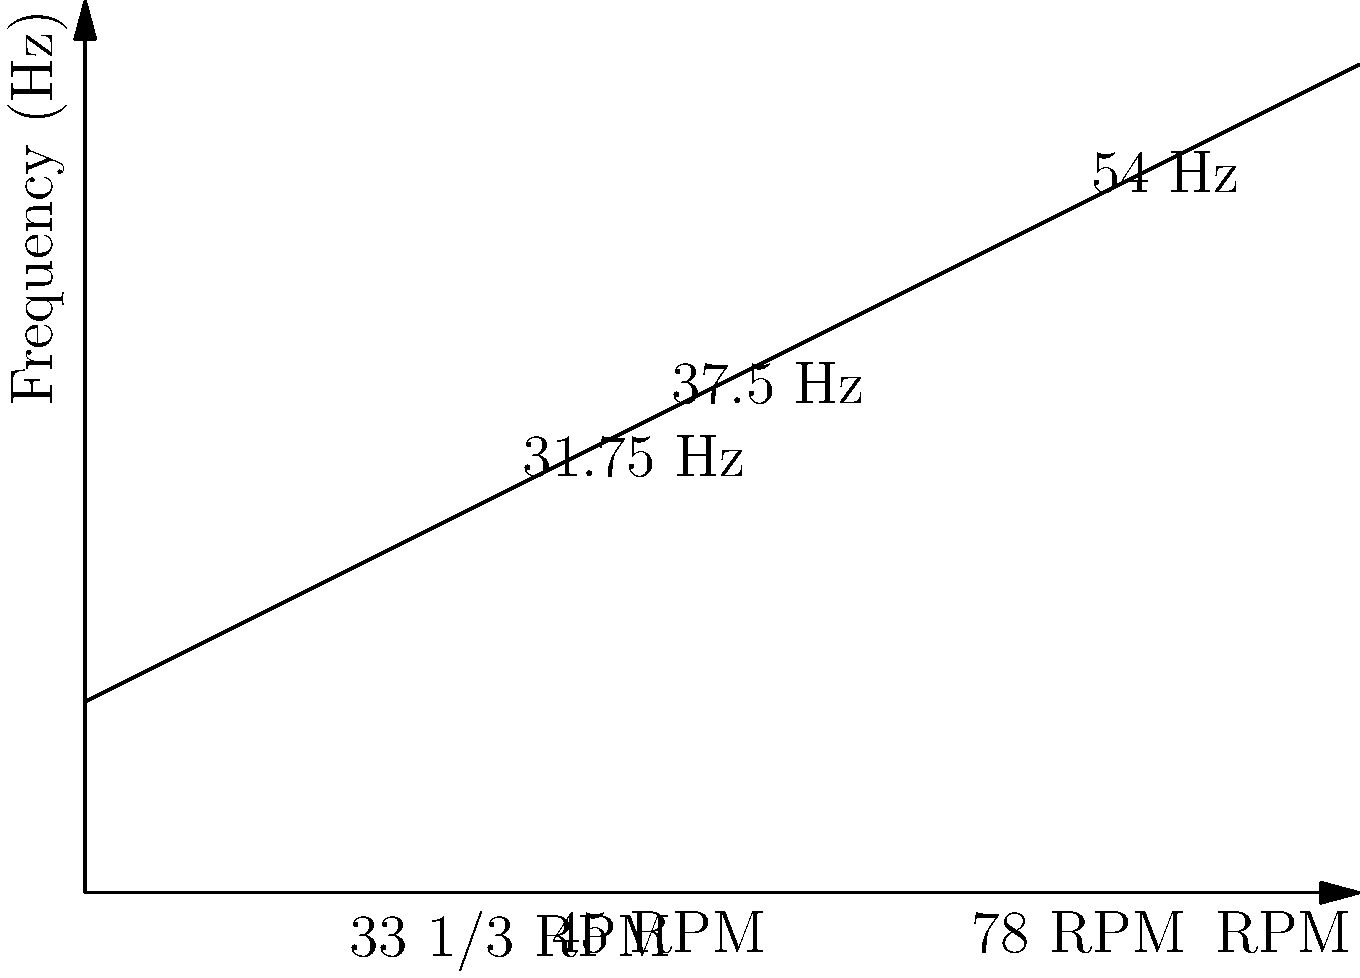As a vinyl enthusiast, you're exploring the relationship between record playback speed and sound frequency. The graph shows the linear relationship between RPM (revolutions per minute) and frequency (Hz) for a particular vinyl record. If you want to achieve a playback frequency of 45 Hz, what would be the ideal RPM setting for your turntable? To solve this problem, we need to follow these steps:

1. Understand the graph: The x-axis represents RPM, and the y-axis represents frequency in Hz. The line shows a linear relationship between these two variables.

2. Identify the equation: The graph represents a linear function of the form $y = mx + b$, where $m$ is the slope and $b$ is the y-intercept.

3. Calculate the slope:
   We can use two known points: (33.33, 31.75) and (78, 54)
   $m = \frac{54 - 31.75}{78 - 33.33} = \frac{22.25}{44.67} \approx 0.5$

4. Find the y-intercept:
   Using the point (33.33, 31.75) and $y = 0.5x + b$
   $31.75 = 0.5(33.33) + b$
   $31.75 = 16.665 + b$
   $b = 15.085 \approx 15$

5. Write the equation:
   $y = 0.5x + 15$, where $y$ is the frequency and $x$ is the RPM

6. Solve for the desired frequency:
   We want $y = 45$ Hz
   $45 = 0.5x + 15$
   $30 = 0.5x$
   $x = 60$

Therefore, to achieve a playback frequency of 45 Hz, the ideal RPM setting would be 60 RPM.
Answer: 60 RPM 